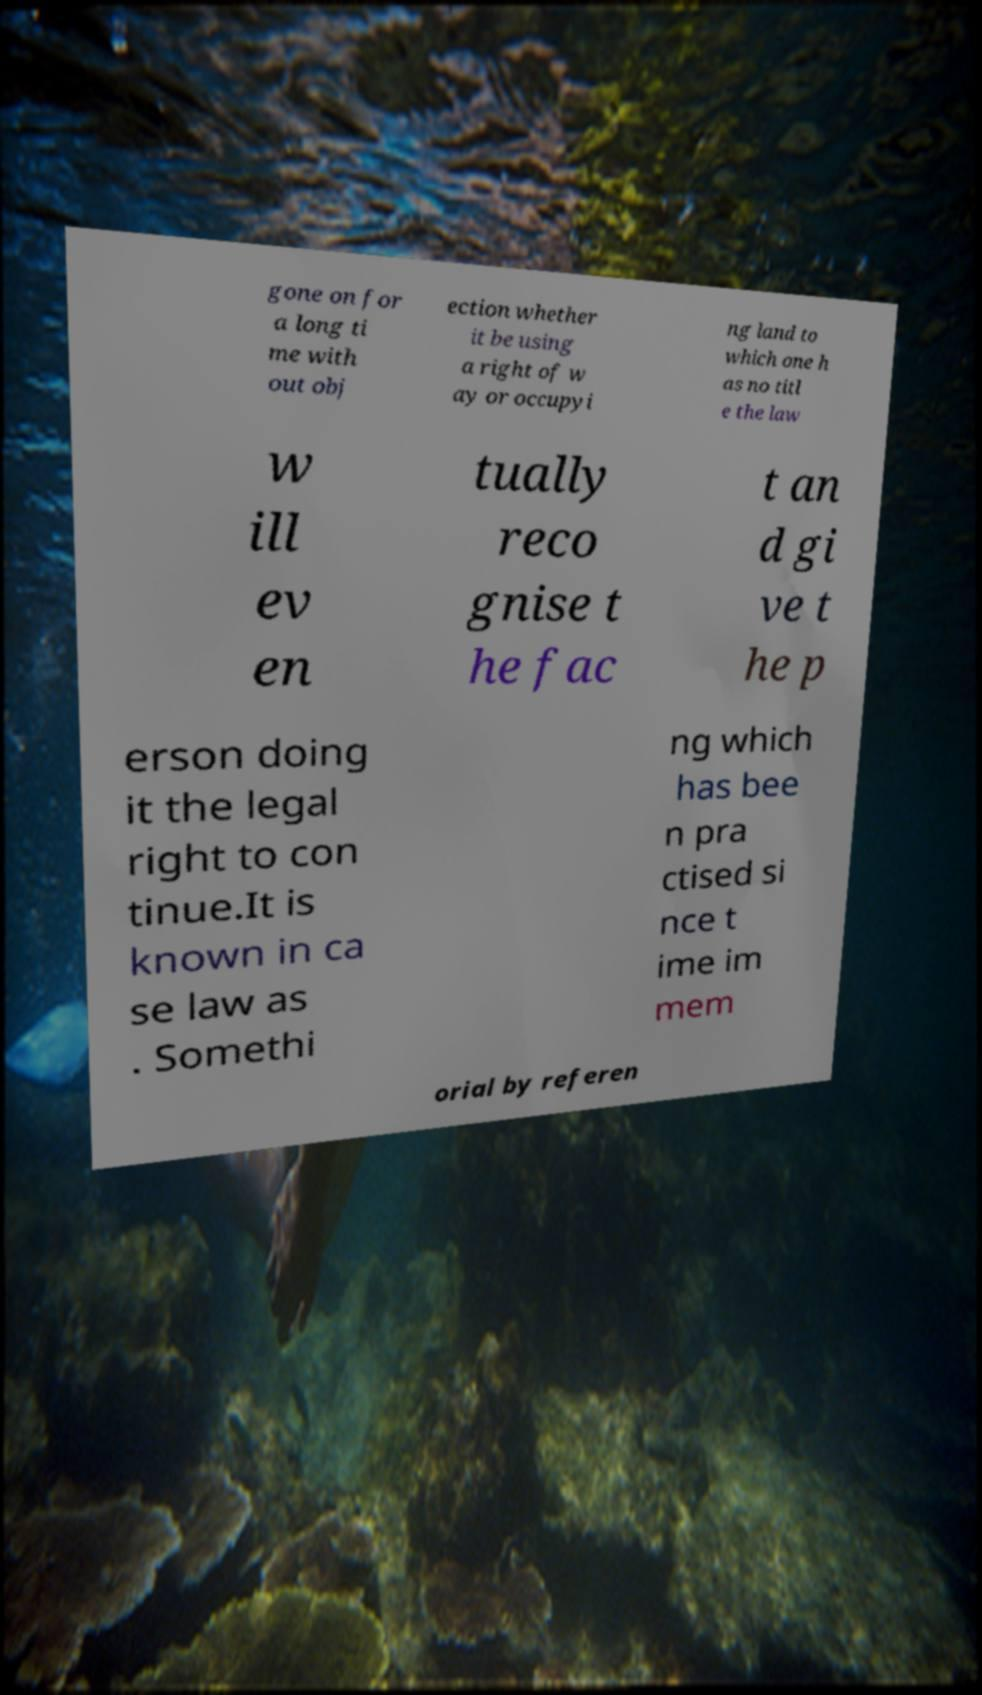Please read and relay the text visible in this image. What does it say? gone on for a long ti me with out obj ection whether it be using a right of w ay or occupyi ng land to which one h as no titl e the law w ill ev en tually reco gnise t he fac t an d gi ve t he p erson doing it the legal right to con tinue.It is known in ca se law as . Somethi ng which has bee n pra ctised si nce t ime im mem orial by referen 